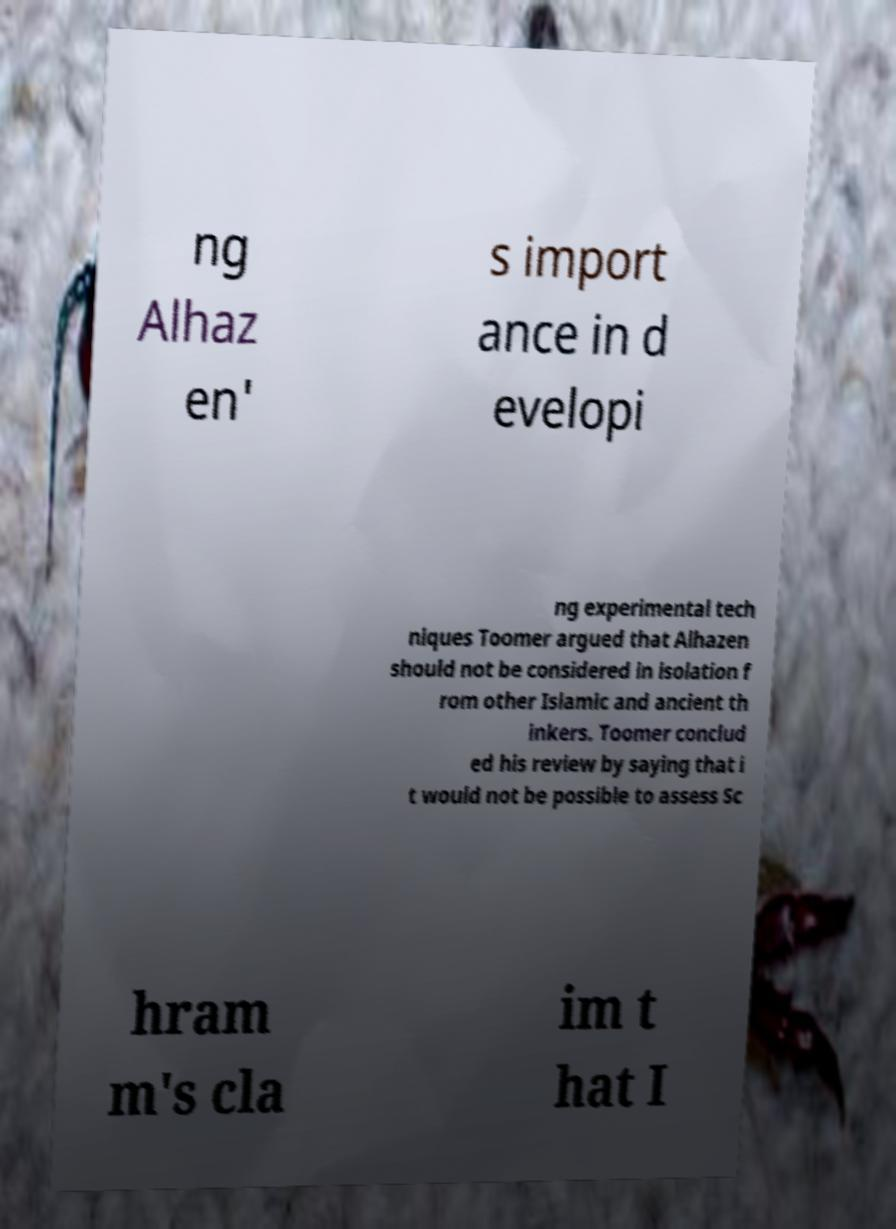I need the written content from this picture converted into text. Can you do that? ng Alhaz en' s import ance in d evelopi ng experimental tech niques Toomer argued that Alhazen should not be considered in isolation f rom other Islamic and ancient th inkers. Toomer conclud ed his review by saying that i t would not be possible to assess Sc hram m's cla im t hat I 